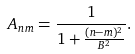Convert formula to latex. <formula><loc_0><loc_0><loc_500><loc_500>A _ { n m } = \frac { 1 } { 1 + \frac { ( n - m ) ^ { 2 } } { B ^ { 2 } } } .</formula> 